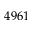Convert formula to latex. <formula><loc_0><loc_0><loc_500><loc_500>4 9 6 1</formula> 